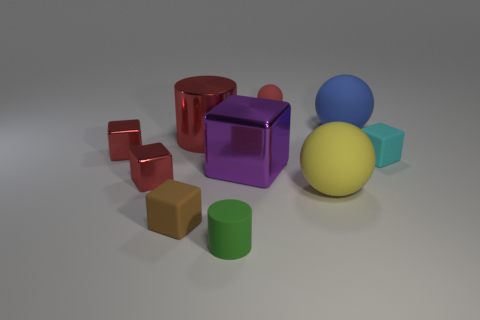There is a cube that is the same material as the cyan object; what is its color?
Your answer should be very brief. Brown. Does the small green cylinder have the same material as the large ball to the left of the blue matte sphere?
Provide a succinct answer. Yes. There is a cube that is both in front of the tiny cyan object and on the left side of the brown thing; what is its color?
Give a very brief answer. Red. How many blocks are big red shiny objects or metallic things?
Your response must be concise. 3. Do the large yellow object and the small red thing behind the large red thing have the same shape?
Offer a terse response. Yes. There is a metal thing that is to the right of the tiny brown matte thing and on the left side of the large purple metal cube; what is its size?
Provide a short and direct response. Large. The tiny green rubber thing is what shape?
Your answer should be compact. Cylinder. There is a cylinder behind the tiny brown rubber cube; are there any big shiny cylinders that are left of it?
Your answer should be very brief. No. There is a matte block that is right of the green cylinder; how many tiny cyan objects are in front of it?
Offer a very short reply. 0. What material is the block that is the same size as the yellow matte ball?
Provide a succinct answer. Metal. 